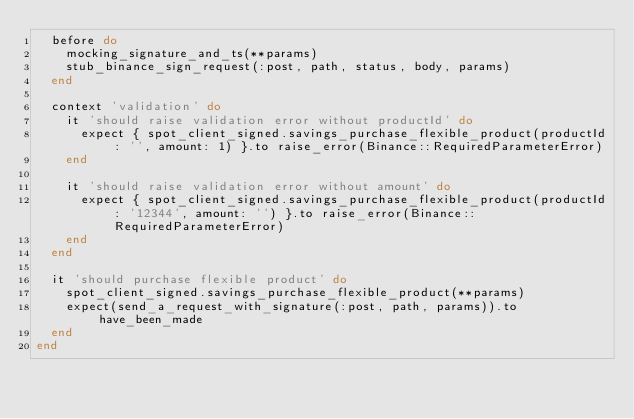Convert code to text. <code><loc_0><loc_0><loc_500><loc_500><_Ruby_>  before do
    mocking_signature_and_ts(**params)
    stub_binance_sign_request(:post, path, status, body, params)
  end

  context 'validation' do
    it 'should raise validation error without productId' do
      expect { spot_client_signed.savings_purchase_flexible_product(productId: '', amount: 1) }.to raise_error(Binance::RequiredParameterError)
    end

    it 'should raise validation error without amount' do
      expect { spot_client_signed.savings_purchase_flexible_product(productId: '12344', amount: '') }.to raise_error(Binance::RequiredParameterError)
    end
  end

  it 'should purchase flexible product' do
    spot_client_signed.savings_purchase_flexible_product(**params)
    expect(send_a_request_with_signature(:post, path, params)).to have_been_made
  end
end
</code> 